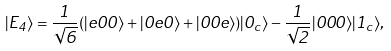<formula> <loc_0><loc_0><loc_500><loc_500>| E _ { 4 } \rangle = \frac { 1 } { \sqrt { 6 } } ( | e 0 0 \rangle + | 0 e 0 \rangle + | 0 0 e \rangle ) | 0 _ { c } \rangle - \frac { 1 } { \sqrt { 2 } } | 0 0 0 \rangle | 1 _ { c } \rangle ,</formula> 